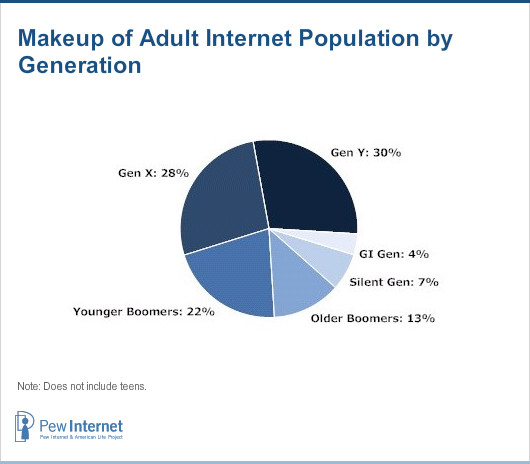Draw attention to some important aspects in this diagram. Gen Y is the number one generation in the chart. 